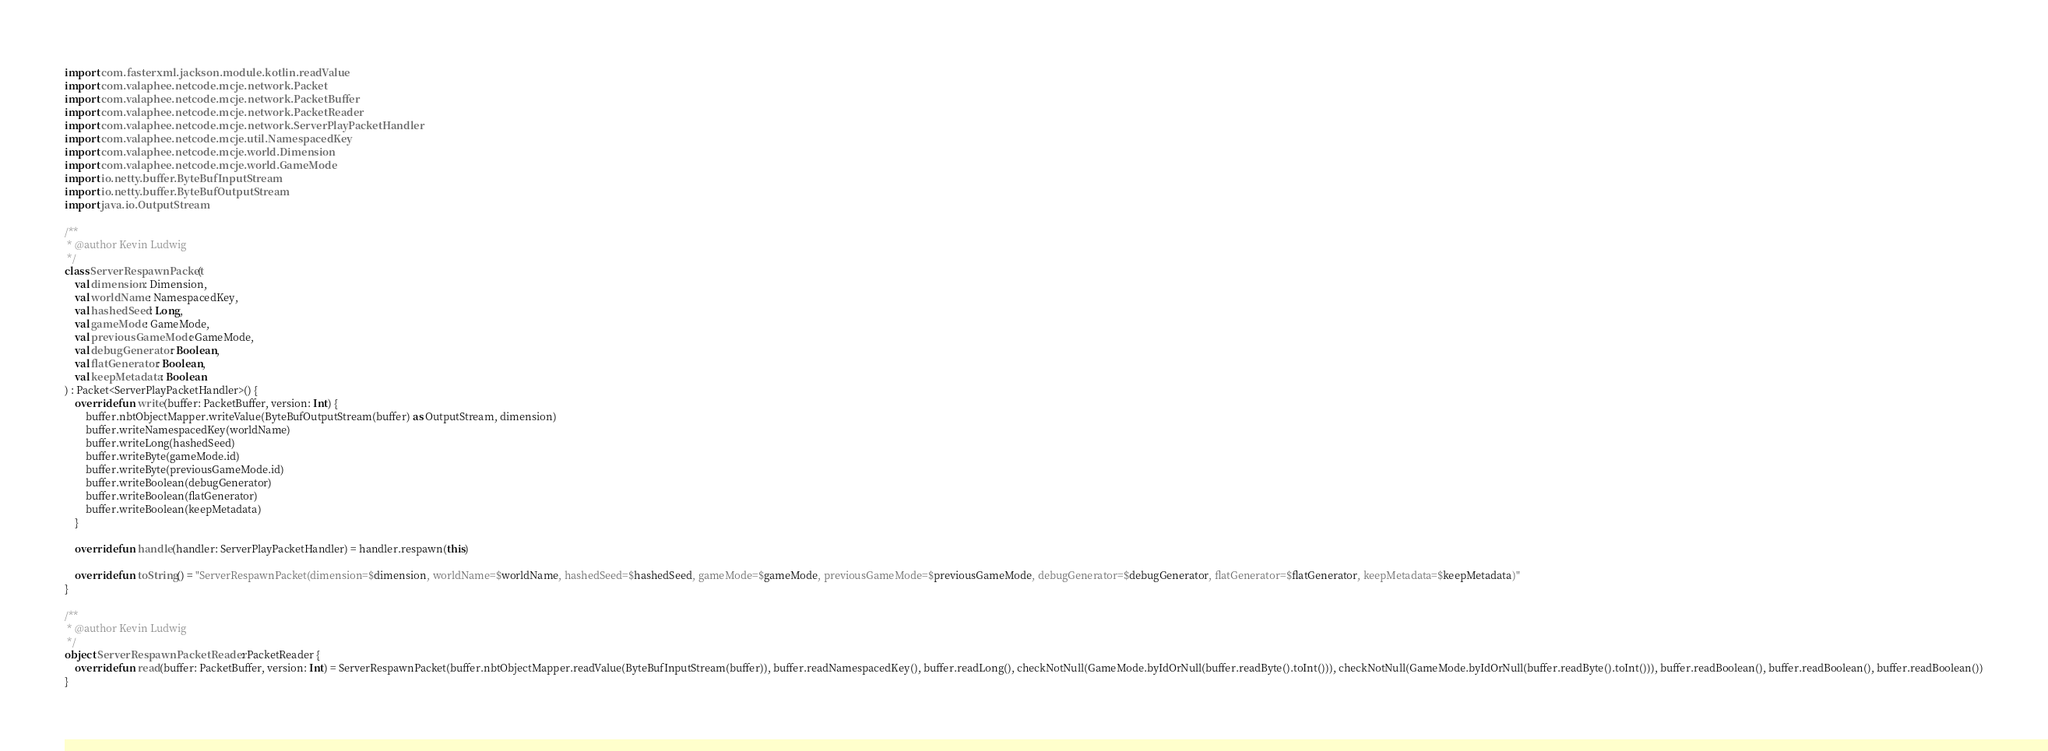Convert code to text. <code><loc_0><loc_0><loc_500><loc_500><_Kotlin_>
import com.fasterxml.jackson.module.kotlin.readValue
import com.valaphee.netcode.mcje.network.Packet
import com.valaphee.netcode.mcje.network.PacketBuffer
import com.valaphee.netcode.mcje.network.PacketReader
import com.valaphee.netcode.mcje.network.ServerPlayPacketHandler
import com.valaphee.netcode.mcje.util.NamespacedKey
import com.valaphee.netcode.mcje.world.Dimension
import com.valaphee.netcode.mcje.world.GameMode
import io.netty.buffer.ByteBufInputStream
import io.netty.buffer.ByteBufOutputStream
import java.io.OutputStream

/**
 * @author Kevin Ludwig
 */
class ServerRespawnPacket(
    val dimension: Dimension,
    val worldName: NamespacedKey,
    val hashedSeed: Long,
    val gameMode: GameMode,
    val previousGameMode: GameMode,
    val debugGenerator: Boolean,
    val flatGenerator: Boolean,
    val keepMetadata: Boolean
) : Packet<ServerPlayPacketHandler>() {
    override fun write(buffer: PacketBuffer, version: Int) {
        buffer.nbtObjectMapper.writeValue(ByteBufOutputStream(buffer) as OutputStream, dimension)
        buffer.writeNamespacedKey(worldName)
        buffer.writeLong(hashedSeed)
        buffer.writeByte(gameMode.id)
        buffer.writeByte(previousGameMode.id)
        buffer.writeBoolean(debugGenerator)
        buffer.writeBoolean(flatGenerator)
        buffer.writeBoolean(keepMetadata)
    }

    override fun handle(handler: ServerPlayPacketHandler) = handler.respawn(this)

    override fun toString() = "ServerRespawnPacket(dimension=$dimension, worldName=$worldName, hashedSeed=$hashedSeed, gameMode=$gameMode, previousGameMode=$previousGameMode, debugGenerator=$debugGenerator, flatGenerator=$flatGenerator, keepMetadata=$keepMetadata)"
}

/**
 * @author Kevin Ludwig
 */
object ServerRespawnPacketReader : PacketReader {
    override fun read(buffer: PacketBuffer, version: Int) = ServerRespawnPacket(buffer.nbtObjectMapper.readValue(ByteBufInputStream(buffer)), buffer.readNamespacedKey(), buffer.readLong(), checkNotNull(GameMode.byIdOrNull(buffer.readByte().toInt())), checkNotNull(GameMode.byIdOrNull(buffer.readByte().toInt())), buffer.readBoolean(), buffer.readBoolean(), buffer.readBoolean())
}
</code> 